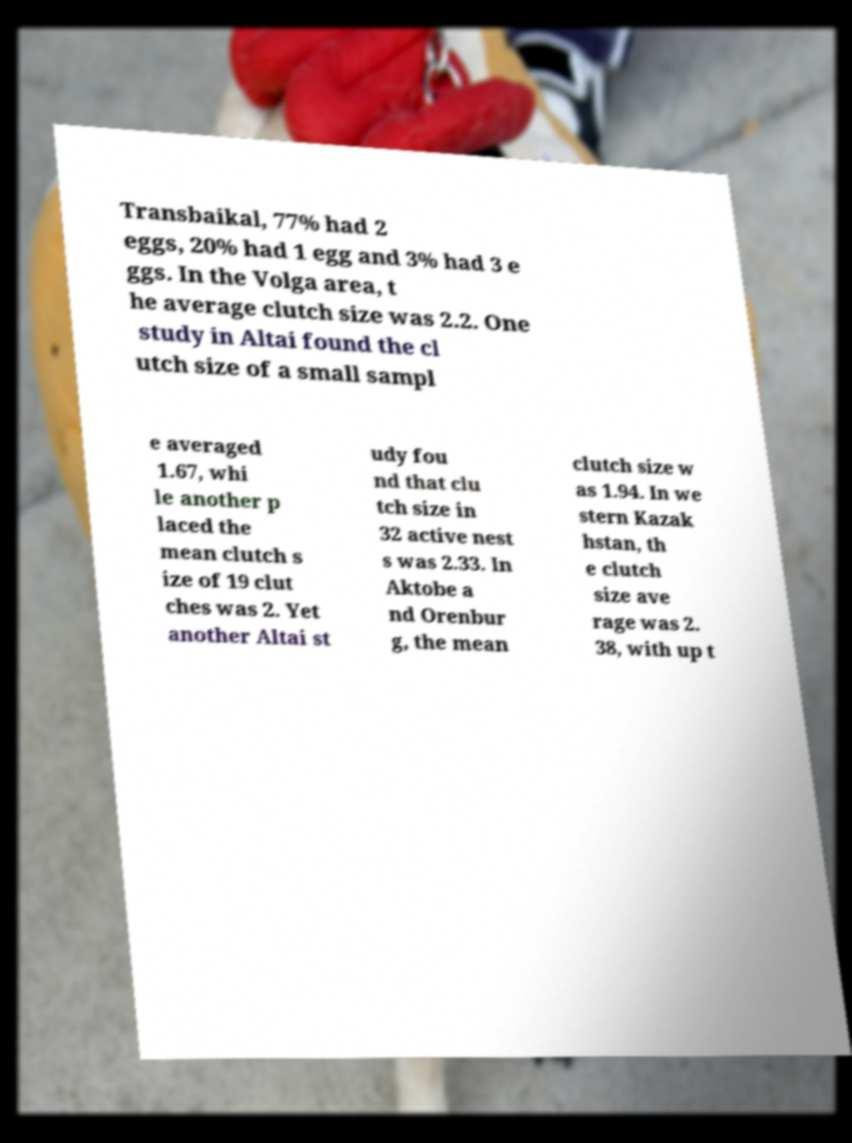For documentation purposes, I need the text within this image transcribed. Could you provide that? Transbaikal, 77% had 2 eggs, 20% had 1 egg and 3% had 3 e ggs. In the Volga area, t he average clutch size was 2.2. One study in Altai found the cl utch size of a small sampl e averaged 1.67, whi le another p laced the mean clutch s ize of 19 clut ches was 2. Yet another Altai st udy fou nd that clu tch size in 32 active nest s was 2.33. In Aktobe a nd Orenbur g, the mean clutch size w as 1.94. In we stern Kazak hstan, th e clutch size ave rage was 2. 38, with up t 